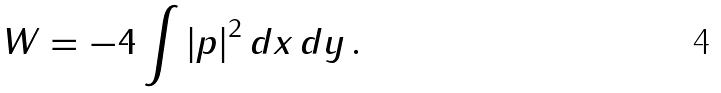Convert formula to latex. <formula><loc_0><loc_0><loc_500><loc_500>W = - 4 \int \left | p \right | ^ { 2 } d x \, d y \, .</formula> 